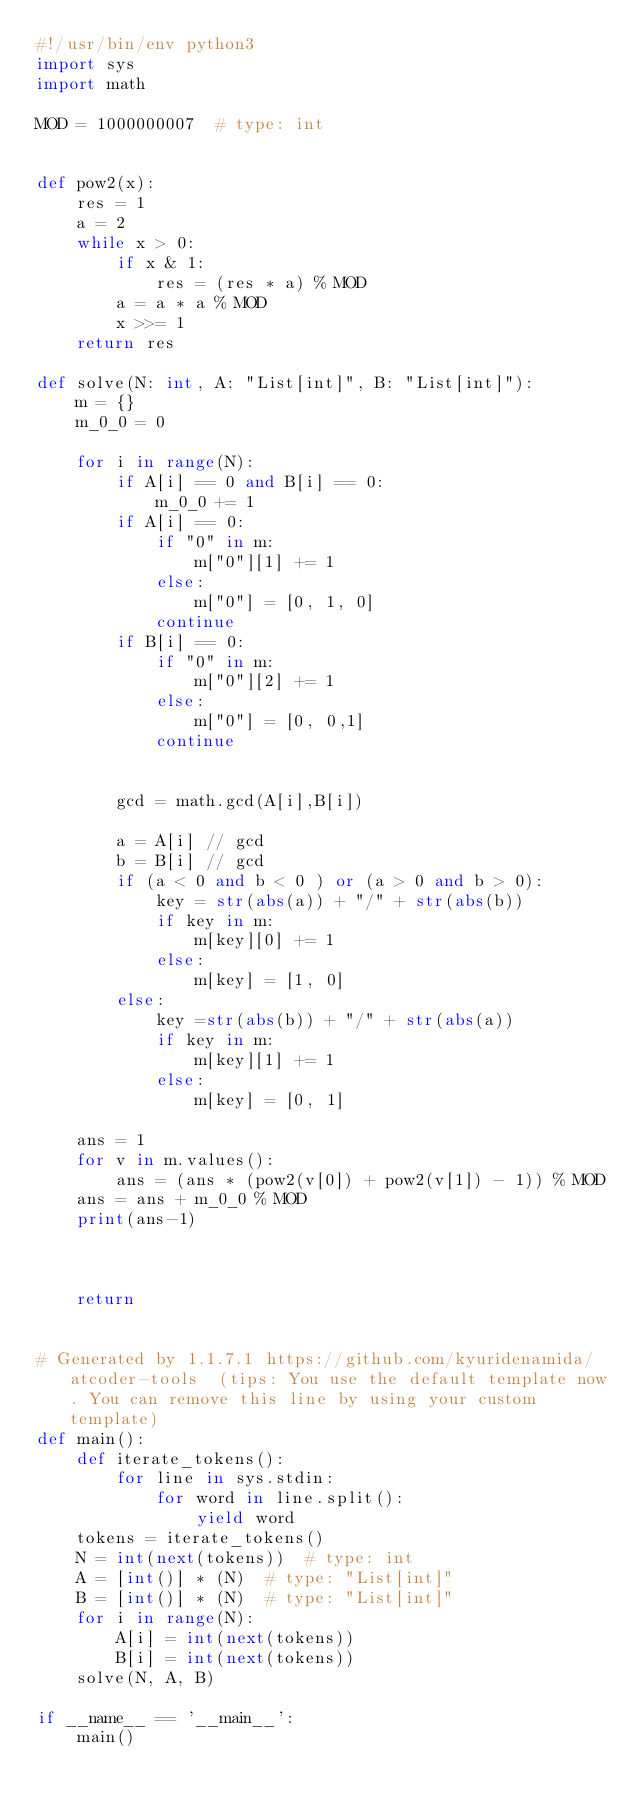Convert code to text. <code><loc_0><loc_0><loc_500><loc_500><_Python_>#!/usr/bin/env python3
import sys
import math

MOD = 1000000007  # type: int


def pow2(x):
    res = 1
    a = 2
    while x > 0:
        if x & 1:
            res = (res * a) % MOD
        a = a * a % MOD
        x >>= 1
    return res

def solve(N: int, A: "List[int]", B: "List[int]"):
    m = {}
    m_0_0 = 0

    for i in range(N):
        if A[i] == 0 and B[i] == 0:
            m_0_0 += 1
        if A[i] == 0:
            if "0" in m:
                m["0"][1] += 1
            else:
                m["0"] = [0, 1, 0]
            continue
        if B[i] == 0:
            if "0" in m:
                m["0"][2] += 1
            else:
                m["0"] = [0, 0,1]
            continue


        gcd = math.gcd(A[i],B[i])

        a = A[i] // gcd
        b = B[i] // gcd
        if (a < 0 and b < 0 ) or (a > 0 and b > 0):
            key = str(abs(a)) + "/" + str(abs(b))
            if key in m:
                m[key][0] += 1
            else:
                m[key] = [1, 0]
        else:
            key =str(abs(b)) + "/" + str(abs(a))
            if key in m:
                m[key][1] += 1
            else:
                m[key] = [0, 1]

    ans = 1
    for v in m.values():
        ans = (ans * (pow2(v[0]) + pow2(v[1]) - 1)) % MOD
    ans = ans + m_0_0 % MOD
    print(ans-1)
            
        

    return


# Generated by 1.1.7.1 https://github.com/kyuridenamida/atcoder-tools  (tips: You use the default template now. You can remove this line by using your custom template)
def main():
    def iterate_tokens():
        for line in sys.stdin:
            for word in line.split():
                yield word
    tokens = iterate_tokens()
    N = int(next(tokens))  # type: int
    A = [int()] * (N)  # type: "List[int]"
    B = [int()] * (N)  # type: "List[int]"
    for i in range(N):
        A[i] = int(next(tokens))
        B[i] = int(next(tokens))
    solve(N, A, B)

if __name__ == '__main__':
    main()
</code> 